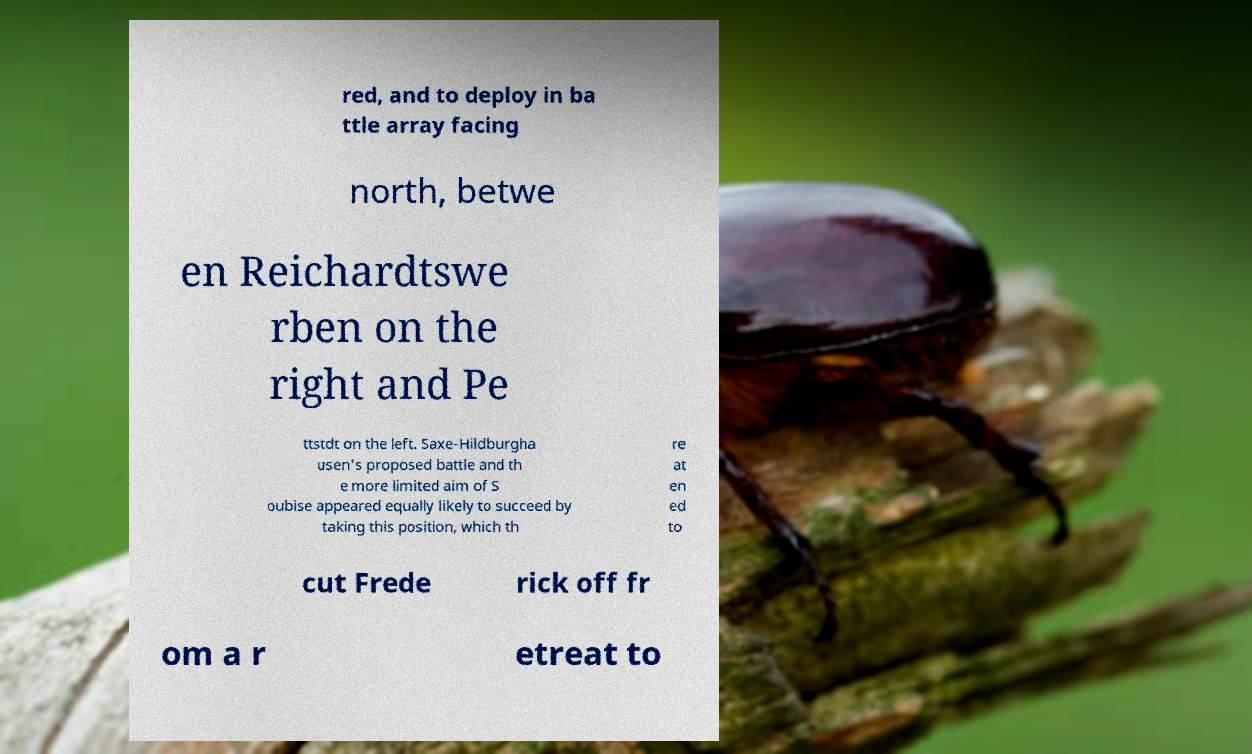What messages or text are displayed in this image? I need them in a readable, typed format. red, and to deploy in ba ttle array facing north, betwe en Reichardtswe rben on the right and Pe ttstdt on the left. Saxe-Hildburgha usen's proposed battle and th e more limited aim of S oubise appeared equally likely to succeed by taking this position, which th re at en ed to cut Frede rick off fr om a r etreat to 